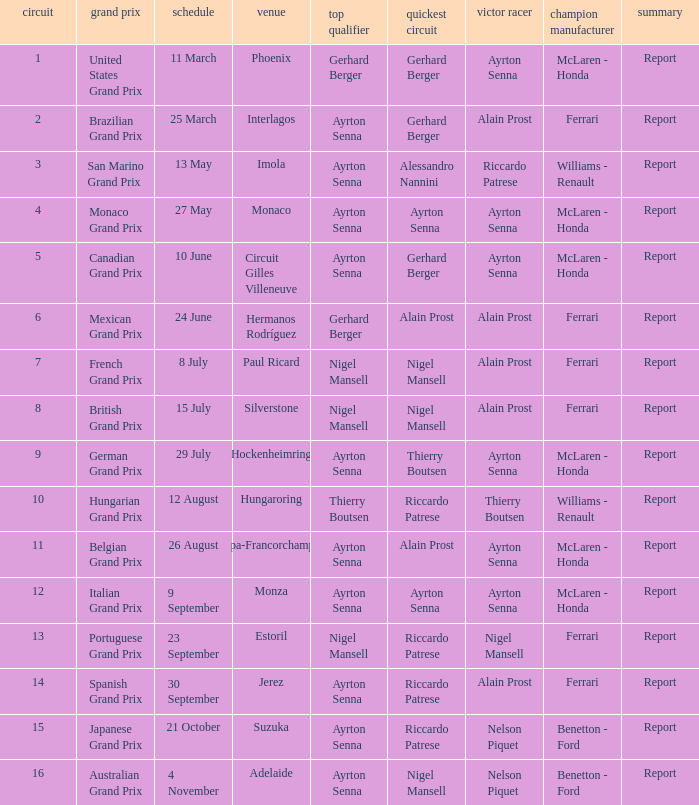What is the date that Ayrton Senna was the drive in Monza? 9 September. 